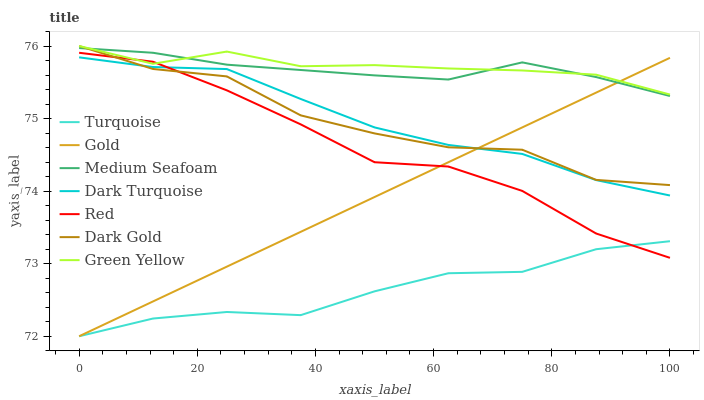Does Turquoise have the minimum area under the curve?
Answer yes or no. Yes. Does Green Yellow have the maximum area under the curve?
Answer yes or no. Yes. Does Gold have the minimum area under the curve?
Answer yes or no. No. Does Gold have the maximum area under the curve?
Answer yes or no. No. Is Gold the smoothest?
Answer yes or no. Yes. Is Dark Gold the roughest?
Answer yes or no. Yes. Is Dark Gold the smoothest?
Answer yes or no. No. Is Gold the roughest?
Answer yes or no. No. Does Turquoise have the lowest value?
Answer yes or no. Yes. Does Dark Gold have the lowest value?
Answer yes or no. No. Does Green Yellow have the highest value?
Answer yes or no. Yes. Does Gold have the highest value?
Answer yes or no. No. Is Turquoise less than Green Yellow?
Answer yes or no. Yes. Is Dark Gold greater than Turquoise?
Answer yes or no. Yes. Does Dark Gold intersect Medium Seafoam?
Answer yes or no. Yes. Is Dark Gold less than Medium Seafoam?
Answer yes or no. No. Is Dark Gold greater than Medium Seafoam?
Answer yes or no. No. Does Turquoise intersect Green Yellow?
Answer yes or no. No. 